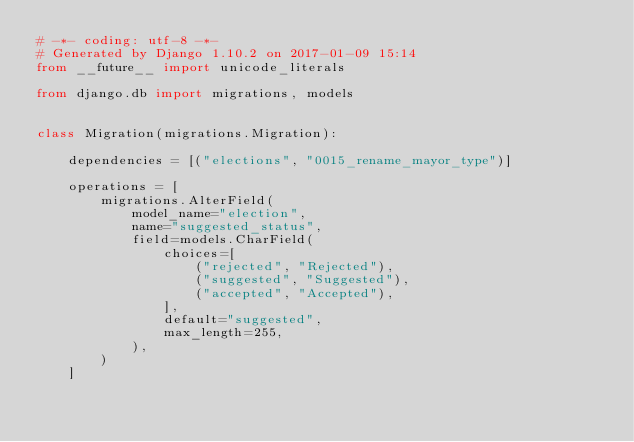Convert code to text. <code><loc_0><loc_0><loc_500><loc_500><_Python_># -*- coding: utf-8 -*-
# Generated by Django 1.10.2 on 2017-01-09 15:14
from __future__ import unicode_literals

from django.db import migrations, models


class Migration(migrations.Migration):

    dependencies = [("elections", "0015_rename_mayor_type")]

    operations = [
        migrations.AlterField(
            model_name="election",
            name="suggested_status",
            field=models.CharField(
                choices=[
                    ("rejected", "Rejected"),
                    ("suggested", "Suggested"),
                    ("accepted", "Accepted"),
                ],
                default="suggested",
                max_length=255,
            ),
        )
    ]
</code> 